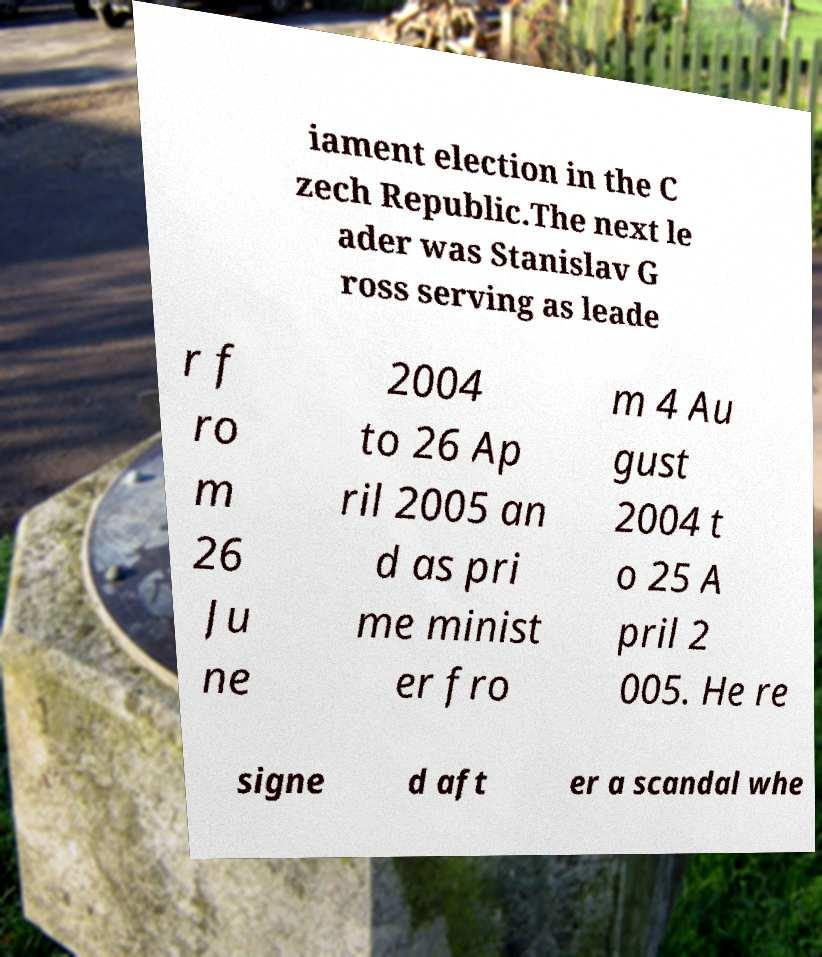Could you assist in decoding the text presented in this image and type it out clearly? iament election in the C zech Republic.The next le ader was Stanislav G ross serving as leade r f ro m 26 Ju ne 2004 to 26 Ap ril 2005 an d as pri me minist er fro m 4 Au gust 2004 t o 25 A pril 2 005. He re signe d aft er a scandal whe 